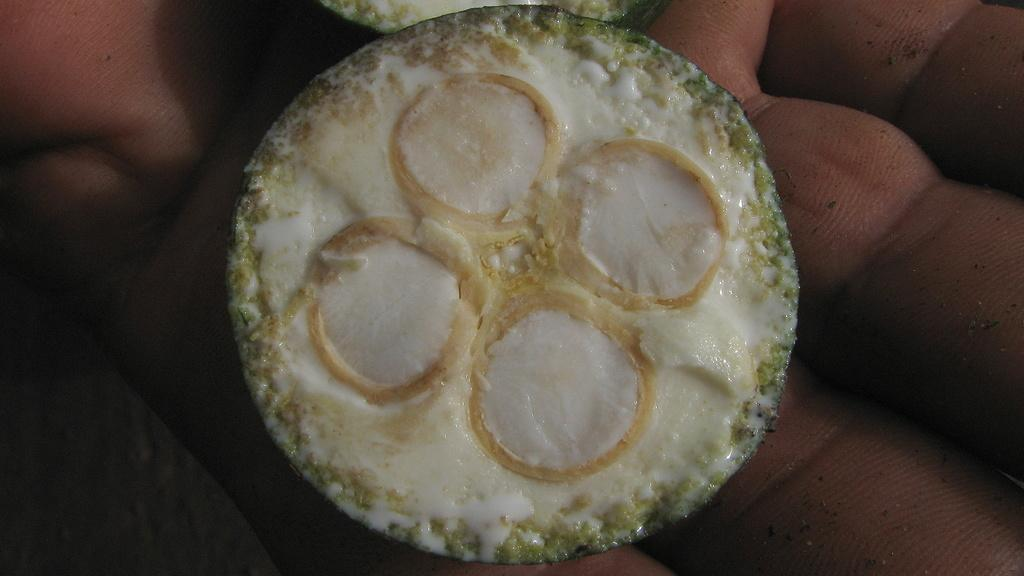What is the main subject of the image? There is a food item in the image. Can you describe the location of the food item? The food item is on the hand of a person. What type of pen is the person holding in the image? There is no pen present in the image; it features a food item on the hand of a person. Can you see any ladybugs on the food item in the image? There are no ladybugs present on the food item in the image. 